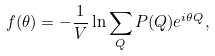<formula> <loc_0><loc_0><loc_500><loc_500>f ( \theta ) = - \frac { 1 } { V } \ln \sum _ { Q } P ( Q ) e ^ { i \theta Q } ,</formula> 